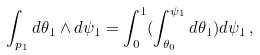<formula> <loc_0><loc_0><loc_500><loc_500>\int _ { p _ { 1 } } d \theta _ { 1 } \wedge d \psi _ { 1 } = \int _ { 0 } ^ { 1 } ( \int _ { \theta _ { 0 } } ^ { \psi _ { 1 } } d \theta _ { 1 } ) d \psi _ { 1 } \, ,</formula> 